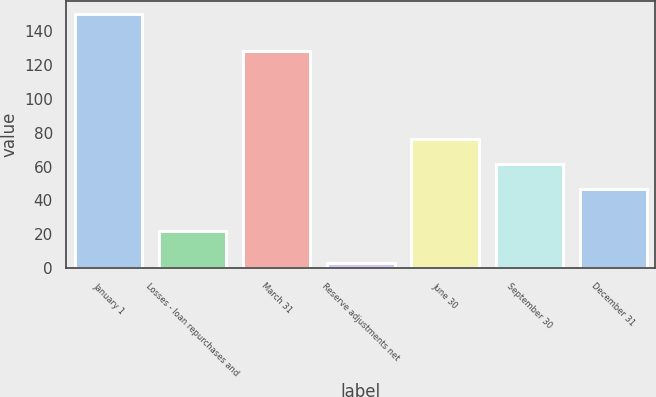Convert chart. <chart><loc_0><loc_0><loc_500><loc_500><bar_chart><fcel>January 1<fcel>Losses - loan repurchases and<fcel>March 31<fcel>Reserve adjustments net<fcel>June 30<fcel>September 30<fcel>December 31<nl><fcel>150<fcel>22<fcel>128<fcel>3<fcel>76.4<fcel>61.7<fcel>47<nl></chart> 